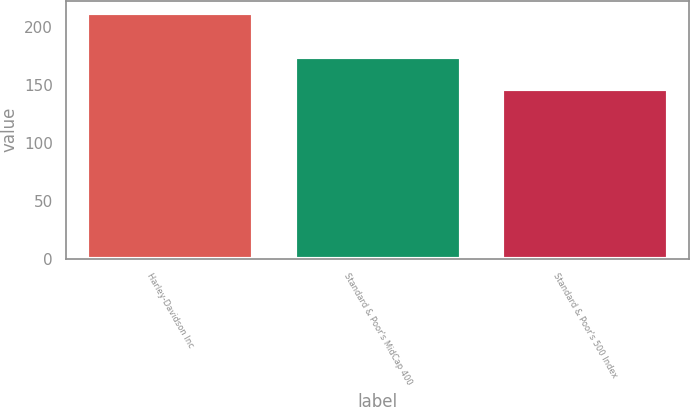Convert chart to OTSL. <chart><loc_0><loc_0><loc_500><loc_500><bar_chart><fcel>Harley-Davidson Inc<fcel>Standard & Poor's MidCap 400<fcel>Standard & Poor's 500 Index<nl><fcel>212<fcel>174<fcel>146<nl></chart> 